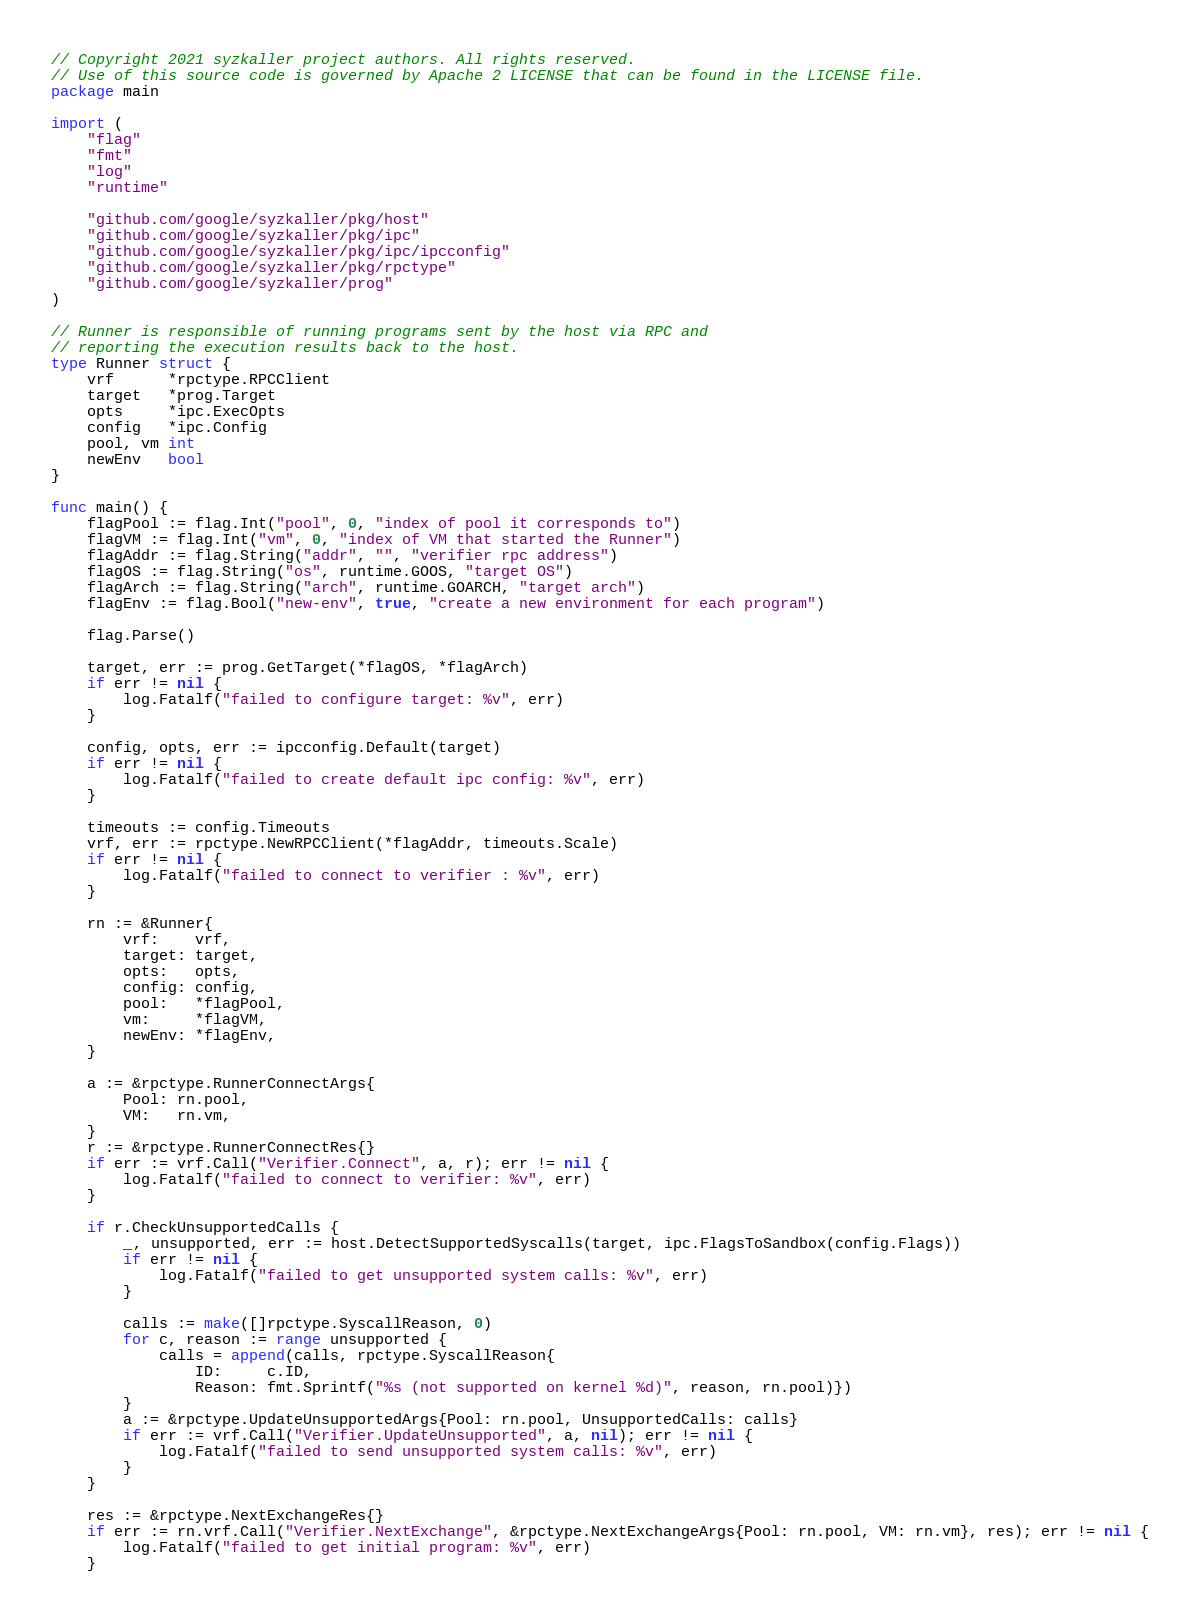<code> <loc_0><loc_0><loc_500><loc_500><_Go_>// Copyright 2021 syzkaller project authors. All rights reserved.
// Use of this source code is governed by Apache 2 LICENSE that can be found in the LICENSE file.
package main

import (
	"flag"
	"fmt"
	"log"
	"runtime"

	"github.com/google/syzkaller/pkg/host"
	"github.com/google/syzkaller/pkg/ipc"
	"github.com/google/syzkaller/pkg/ipc/ipcconfig"
	"github.com/google/syzkaller/pkg/rpctype"
	"github.com/google/syzkaller/prog"
)

// Runner is responsible of running programs sent by the host via RPC and
// reporting the execution results back to the host.
type Runner struct {
	vrf      *rpctype.RPCClient
	target   *prog.Target
	opts     *ipc.ExecOpts
	config   *ipc.Config
	pool, vm int
	newEnv   bool
}

func main() {
	flagPool := flag.Int("pool", 0, "index of pool it corresponds to")
	flagVM := flag.Int("vm", 0, "index of VM that started the Runner")
	flagAddr := flag.String("addr", "", "verifier rpc address")
	flagOS := flag.String("os", runtime.GOOS, "target OS")
	flagArch := flag.String("arch", runtime.GOARCH, "target arch")
	flagEnv := flag.Bool("new-env", true, "create a new environment for each program")

	flag.Parse()

	target, err := prog.GetTarget(*flagOS, *flagArch)
	if err != nil {
		log.Fatalf("failed to configure target: %v", err)
	}

	config, opts, err := ipcconfig.Default(target)
	if err != nil {
		log.Fatalf("failed to create default ipc config: %v", err)
	}

	timeouts := config.Timeouts
	vrf, err := rpctype.NewRPCClient(*flagAddr, timeouts.Scale)
	if err != nil {
		log.Fatalf("failed to connect to verifier : %v", err)
	}

	rn := &Runner{
		vrf:    vrf,
		target: target,
		opts:   opts,
		config: config,
		pool:   *flagPool,
		vm:     *flagVM,
		newEnv: *flagEnv,
	}

	a := &rpctype.RunnerConnectArgs{
		Pool: rn.pool,
		VM:   rn.vm,
	}
	r := &rpctype.RunnerConnectRes{}
	if err := vrf.Call("Verifier.Connect", a, r); err != nil {
		log.Fatalf("failed to connect to verifier: %v", err)
	}

	if r.CheckUnsupportedCalls {
		_, unsupported, err := host.DetectSupportedSyscalls(target, ipc.FlagsToSandbox(config.Flags))
		if err != nil {
			log.Fatalf("failed to get unsupported system calls: %v", err)
		}

		calls := make([]rpctype.SyscallReason, 0)
		for c, reason := range unsupported {
			calls = append(calls, rpctype.SyscallReason{
				ID:     c.ID,
				Reason: fmt.Sprintf("%s (not supported on kernel %d)", reason, rn.pool)})
		}
		a := &rpctype.UpdateUnsupportedArgs{Pool: rn.pool, UnsupportedCalls: calls}
		if err := vrf.Call("Verifier.UpdateUnsupported", a, nil); err != nil {
			log.Fatalf("failed to send unsupported system calls: %v", err)
		}
	}

	res := &rpctype.NextExchangeRes{}
	if err := rn.vrf.Call("Verifier.NextExchange", &rpctype.NextExchangeArgs{Pool: rn.pool, VM: rn.vm}, res); err != nil {
		log.Fatalf("failed to get initial program: %v", err)
	}
</code> 